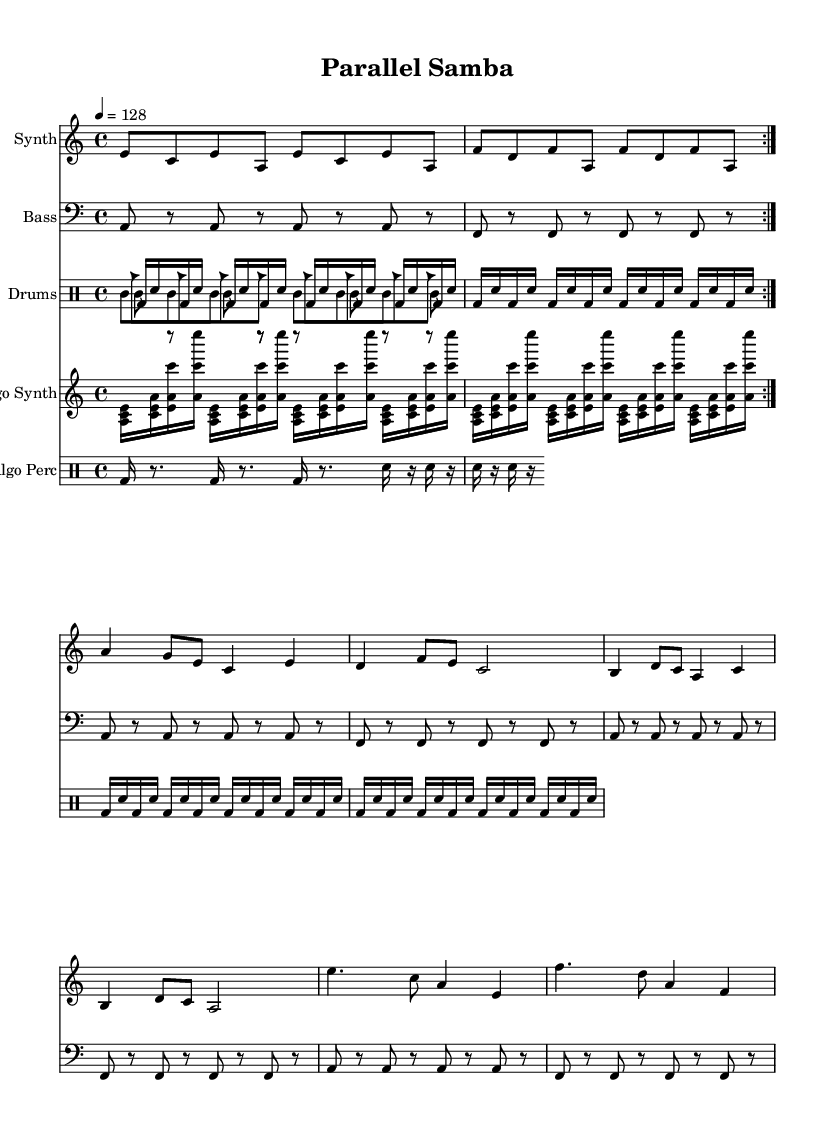What is the key signature of this music? The key signature is indicated at the beginning of the score, which shows one flat (B♭). This key signature corresponds to A minor.
Answer: A minor What is the time signature of this music? The time signature is found at the beginning of the piece, and it is 4/4, meaning there are four beats per measure.
Answer: 4/4 What is the tempo marking of the piece? The tempo is indicated above the staff with the marking '4 = 128,' meaning one quarter note equals 128 beats per minute.
Answer: 128 How many measures are present in the synth part? Counting the measures in the synth part, there are a total of 16 measures in this section.
Answer: 16 Which rhythmic instrument pattern plays the clave? The clave pattern is designated in the drum part with cl indicating the clave rhythm. It consists of alternating notes and rests giving a syncopated feel typical in Latin music.
Answer: clave What are the two primary sections in the drums part? The drums part is divided into two sections: a repetitive kick-snare pattern and rhythm patterns for the clave and cowbell, demonstrating interplay characteristic in Latin rhythms.
Answer: kick-snare and rhythm patterns What type of music style is this piece an example of? This piece combines features of traditional Latin music with electronic elements and algorithmic rhythms, representing a fusion style that melds the genres.
Answer: Latin electronic fusion 